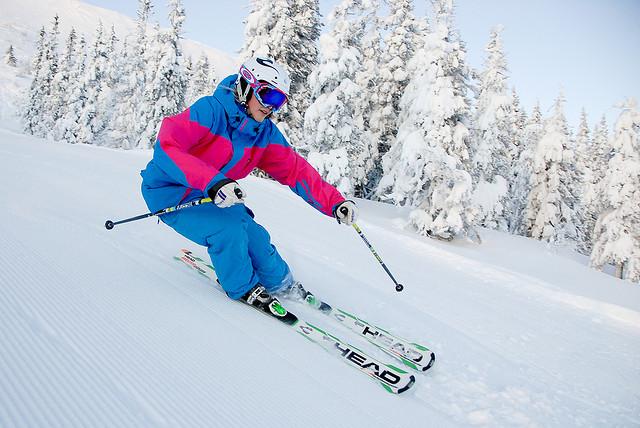Is the person using HEAD skis?
Answer briefly. Yes. What is in the picture?
Be succinct. Skier. What is the season?
Keep it brief. Winter. 